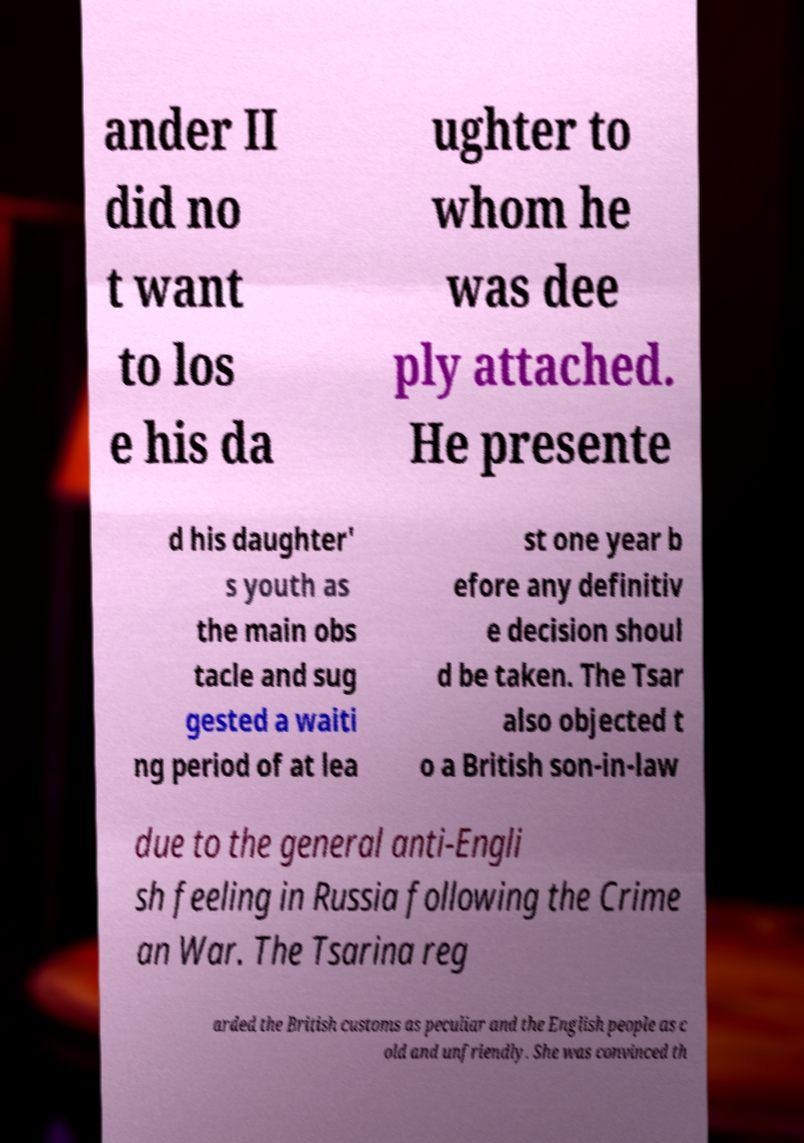What messages or text are displayed in this image? I need them in a readable, typed format. ander II did no t want to los e his da ughter to whom he was dee ply attached. He presente d his daughter' s youth as the main obs tacle and sug gested a waiti ng period of at lea st one year b efore any definitiv e decision shoul d be taken. The Tsar also objected t o a British son-in-law due to the general anti-Engli sh feeling in Russia following the Crime an War. The Tsarina reg arded the British customs as peculiar and the English people as c old and unfriendly. She was convinced th 